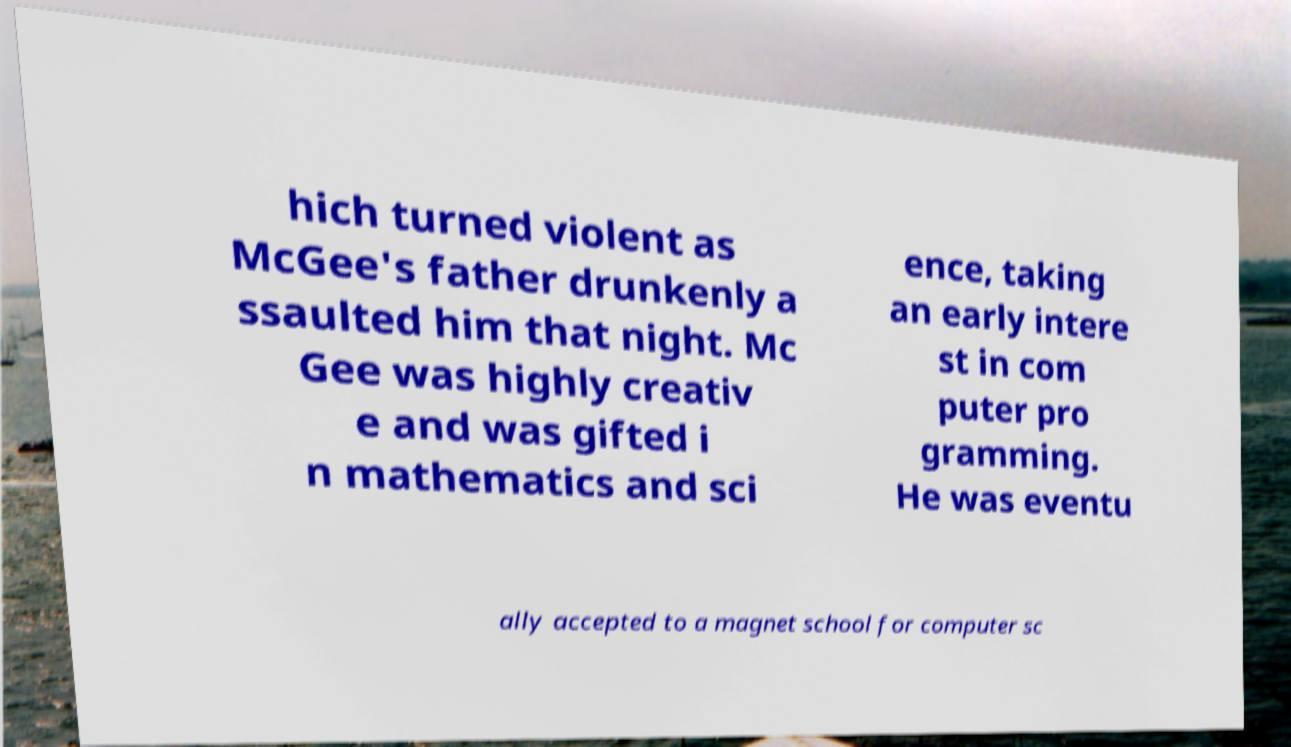Please read and relay the text visible in this image. What does it say? hich turned violent as McGee's father drunkenly a ssaulted him that night. Mc Gee was highly creativ e and was gifted i n mathematics and sci ence, taking an early intere st in com puter pro gramming. He was eventu ally accepted to a magnet school for computer sc 